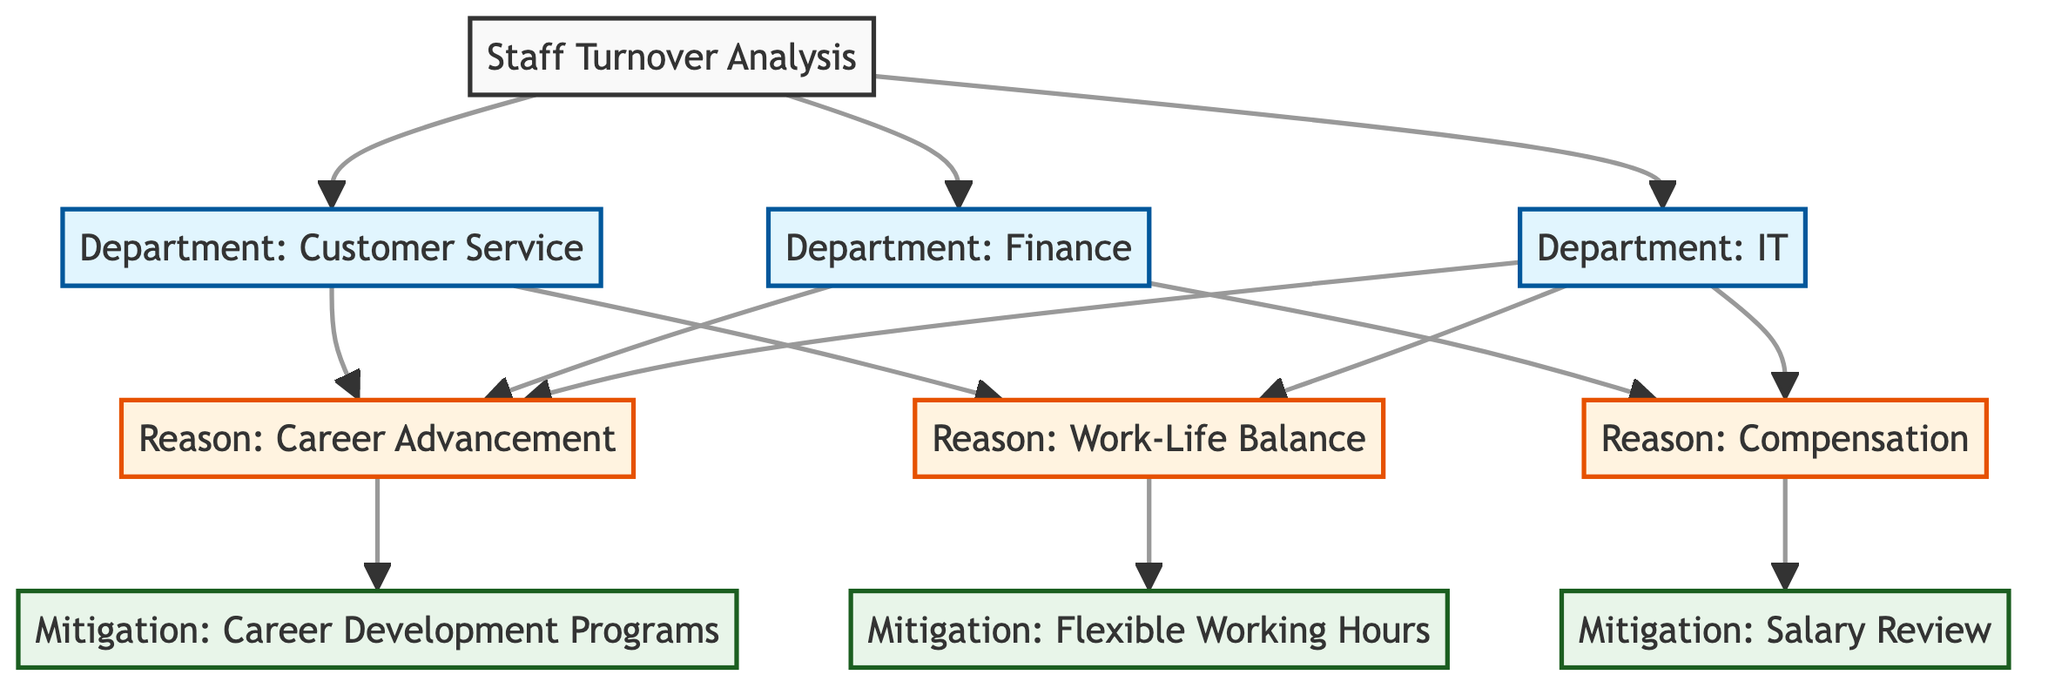What are the departments included in the turnover analysis? The diagram lists three departments: IT, Finance, and Customer Service. This can be seen by looking at the nodes that branch from the main node labeled "Staff Turnover Analysis."
Answer: IT, Finance, Customer Service How many reasons for leaving are identified in the diagram? The diagram shows three distinct reasons for leaving that are connected to the departments, specifically Career Advancement, Work-Life Balance, and Compensation. Counting the nodes connected to the departments gives a total of three reasons.
Answer: 3 Which department has a connection to the reason “Work-Life Balance”? The department Customer Service is connected to the reason Work-Life Balance, as indicated by the directed edge from the Customer Service department to the Work-Life Balance node in the diagram.
Answer: Customer Service What mitigation strategy is associated with “Career Advancement”? The mitigation strategy linked to Career Advancement is Career Development Programs. This can be understood by following the arrow from Career Advancement to its corresponding mitigation node.
Answer: Career Development Programs Which department is linked to both “Compensation” and “Career Advancement”? The department Finance is associated with both Compensation and Career Advancement. This can be inferred by tracing the arrows from the Finance department to both reasons, confirming dual connections.
Answer: Finance How many mitigation strategies are shown in the diagram? The diagram presents three mitigation strategies: Career Development Programs, Flexible Working Hours, and Salary Review. Counting the mitigation nodes provides a total of three strategies.
Answer: 3 Which reason is connected to the most departments? The reason Career Advancement is connected to both the IT and Finance departments. By examining the connections from the departments to the reasons, we see Career Advancement appears in two distinct department-related edges.
Answer: Career Advancement What is the relationship between “Flexible Working Hours” and “Work-Life Balance”? Flexible Working Hours is categorized as a mitigation strategy in response to the reason Work-Life Balance. This relationship can be traced through the arrows leading from Work-Life Balance to its corresponding mitigation strategy.
Answer: Mitigation strategy 